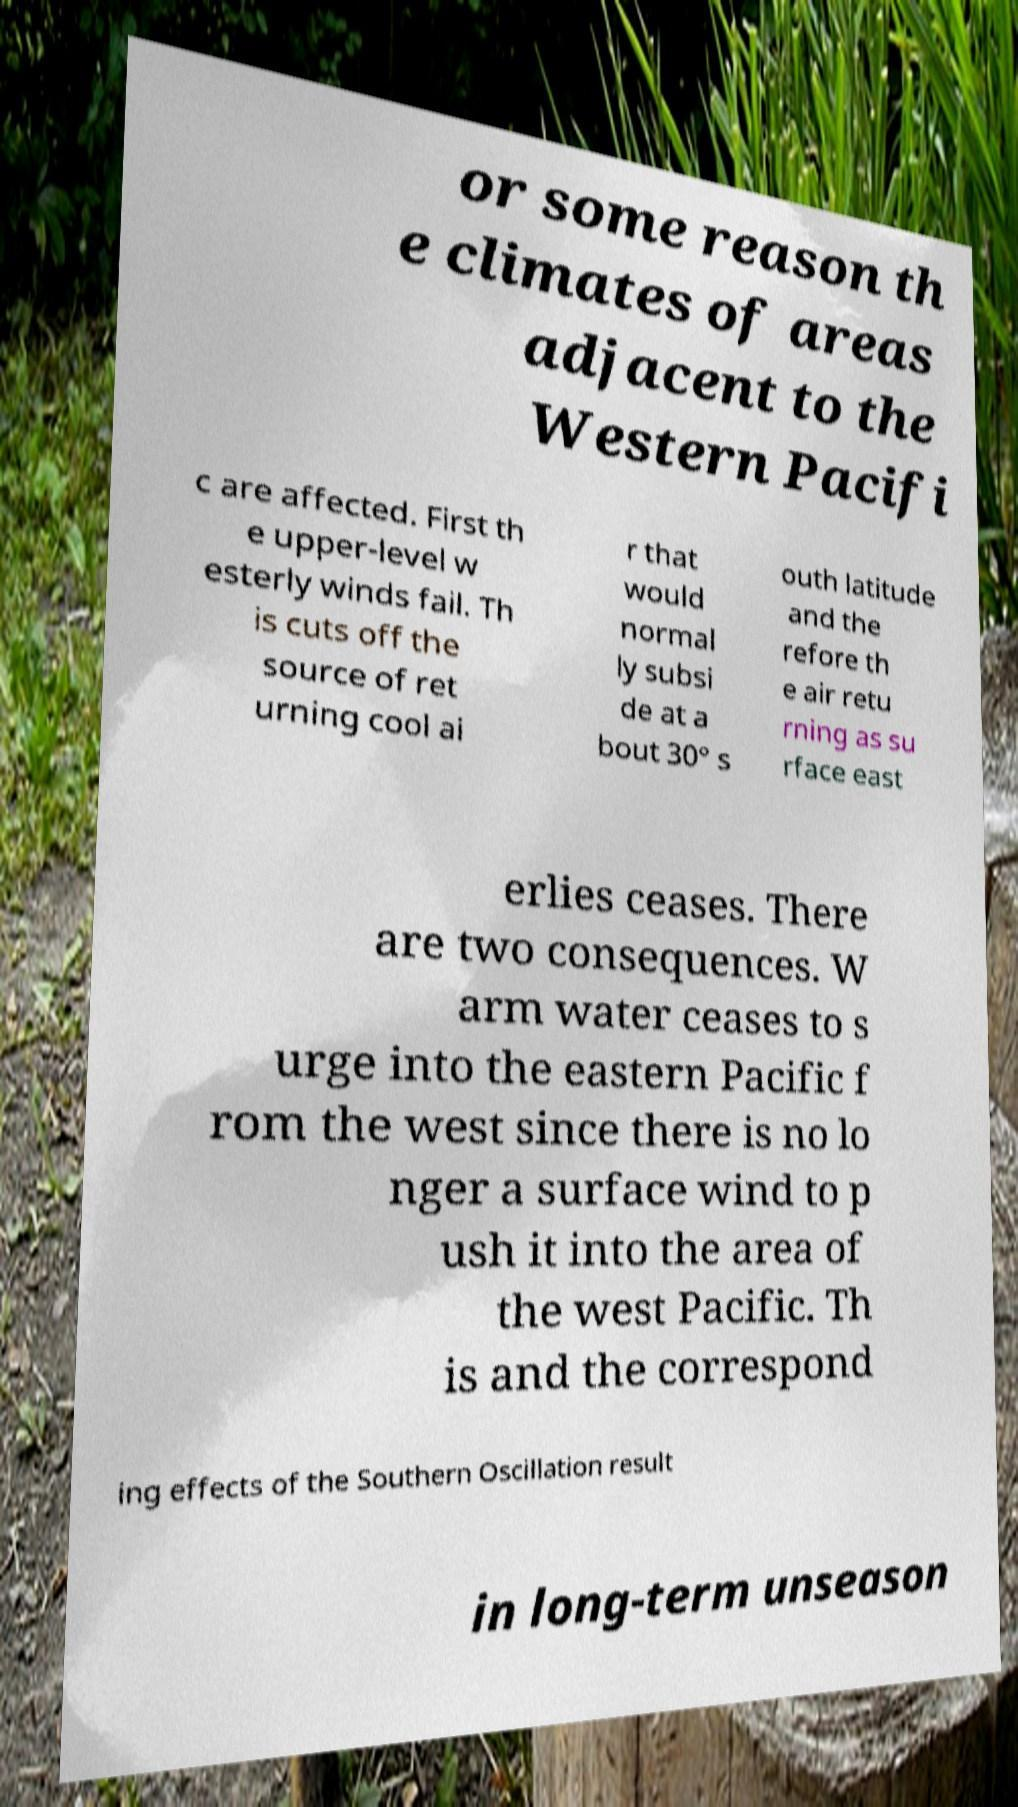Please identify and transcribe the text found in this image. or some reason th e climates of areas adjacent to the Western Pacifi c are affected. First th e upper-level w esterly winds fail. Th is cuts off the source of ret urning cool ai r that would normal ly subsi de at a bout 30° s outh latitude and the refore th e air retu rning as su rface east erlies ceases. There are two consequences. W arm water ceases to s urge into the eastern Pacific f rom the west since there is no lo nger a surface wind to p ush it into the area of the west Pacific. Th is and the correspond ing effects of the Southern Oscillation result in long-term unseason 